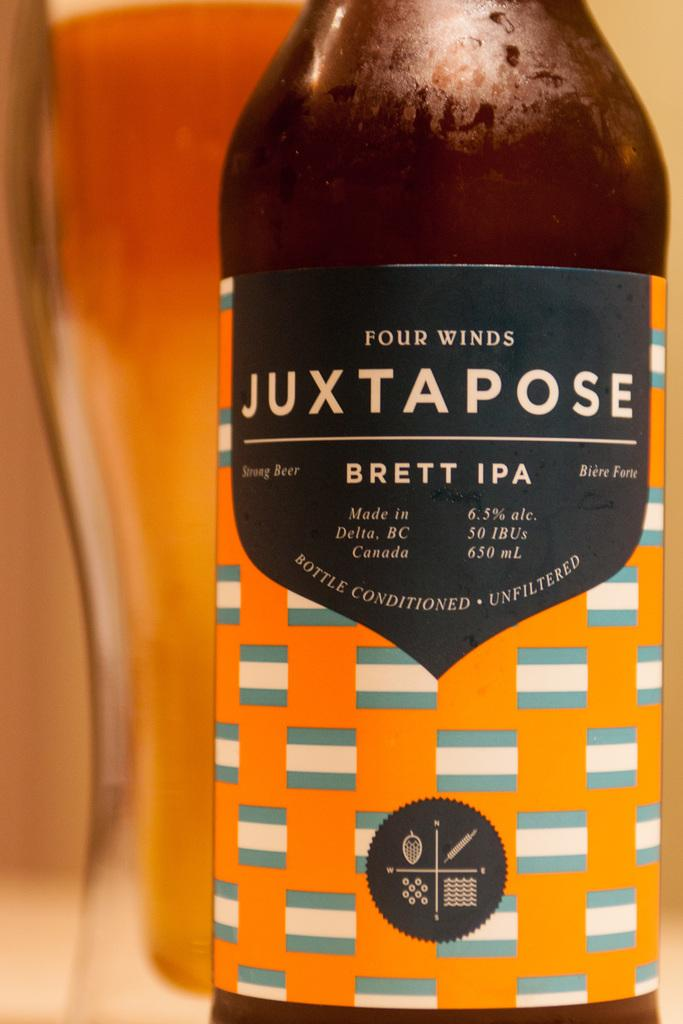Provide a one-sentence caption for the provided image. Bottle for Four Winds Juxtapose with a label showing blue and white flags. 